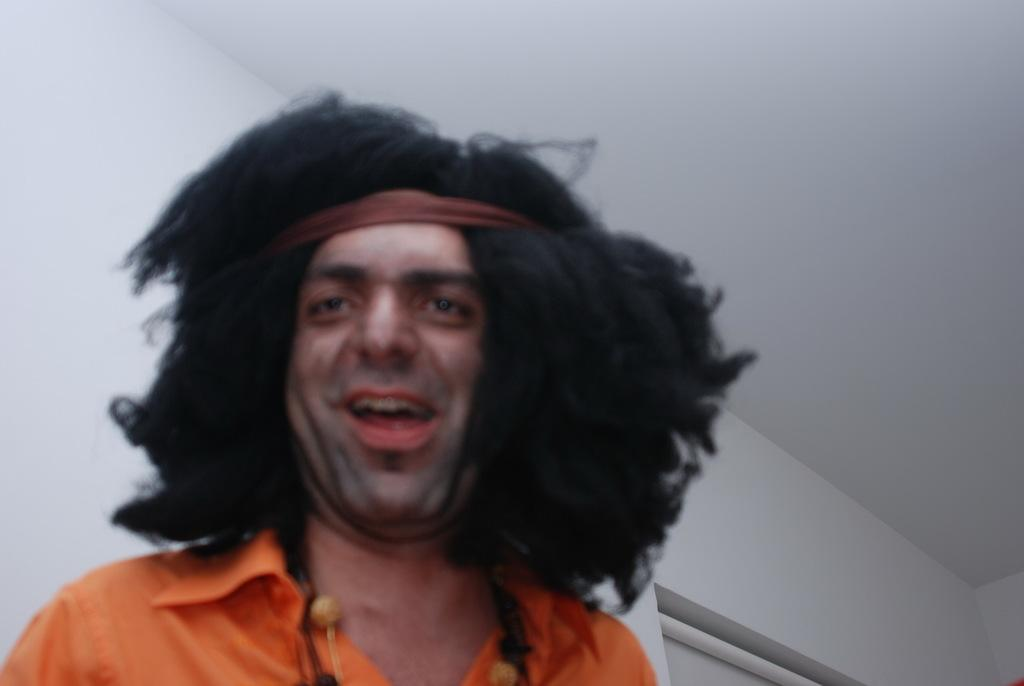What is present in the image? There is a man in the image. What is the man doing in the image? The man is smiling. What can be seen in the background of the image? There is a wall and a roof in the background of the image. Is the man in the image arguing with someone? There is no indication in the image that the man is arguing with someone; he is simply smiling. Can you see any sheep in the image? There are no sheep present in the image. 